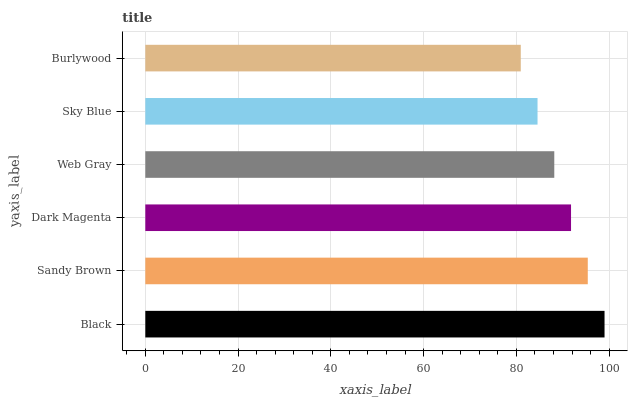Is Burlywood the minimum?
Answer yes or no. Yes. Is Black the maximum?
Answer yes or no. Yes. Is Sandy Brown the minimum?
Answer yes or no. No. Is Sandy Brown the maximum?
Answer yes or no. No. Is Black greater than Sandy Brown?
Answer yes or no. Yes. Is Sandy Brown less than Black?
Answer yes or no. Yes. Is Sandy Brown greater than Black?
Answer yes or no. No. Is Black less than Sandy Brown?
Answer yes or no. No. Is Dark Magenta the high median?
Answer yes or no. Yes. Is Web Gray the low median?
Answer yes or no. Yes. Is Burlywood the high median?
Answer yes or no. No. Is Sandy Brown the low median?
Answer yes or no. No. 